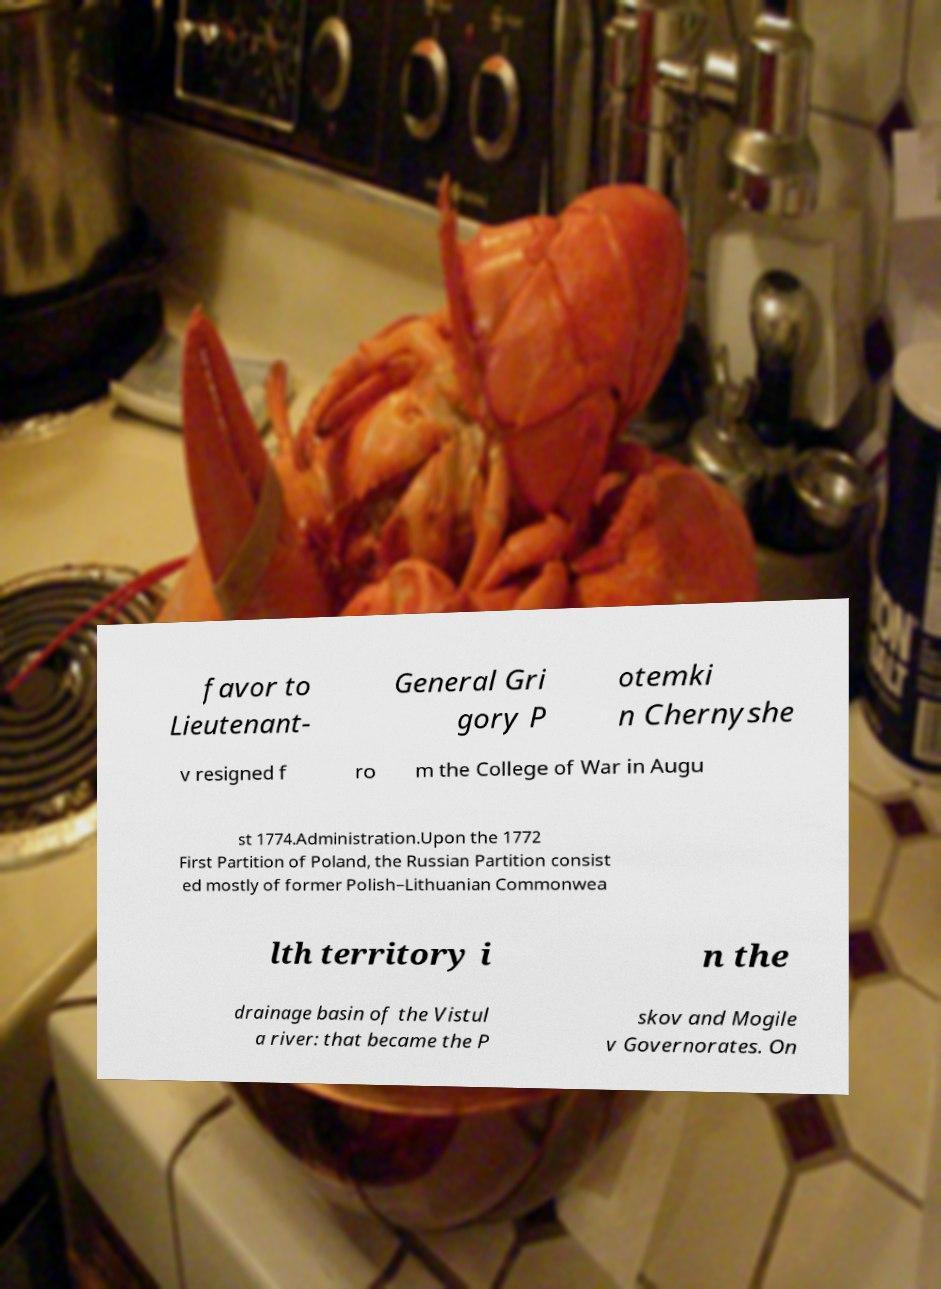For documentation purposes, I need the text within this image transcribed. Could you provide that? favor to Lieutenant- General Gri gory P otemki n Chernyshe v resigned f ro m the College of War in Augu st 1774.Administration.Upon the 1772 First Partition of Poland, the Russian Partition consist ed mostly of former Polish–Lithuanian Commonwea lth territory i n the drainage basin of the Vistul a river: that became the P skov and Mogile v Governorates. On 